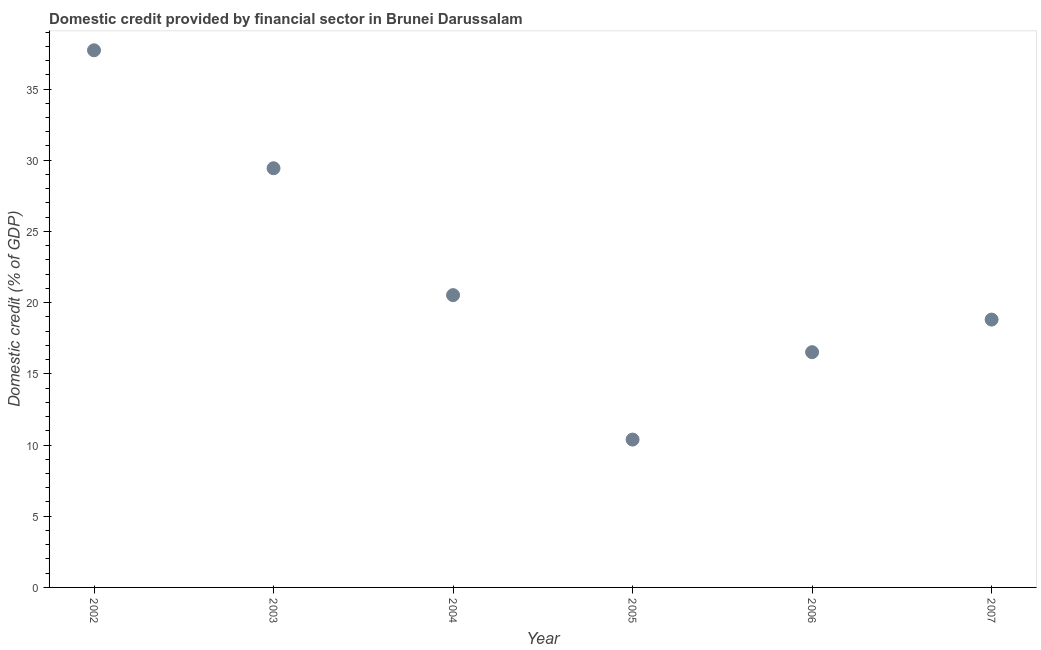What is the domestic credit provided by financial sector in 2005?
Offer a very short reply. 10.38. Across all years, what is the maximum domestic credit provided by financial sector?
Offer a terse response. 37.72. Across all years, what is the minimum domestic credit provided by financial sector?
Offer a very short reply. 10.38. In which year was the domestic credit provided by financial sector minimum?
Ensure brevity in your answer.  2005. What is the sum of the domestic credit provided by financial sector?
Your answer should be compact. 133.39. What is the difference between the domestic credit provided by financial sector in 2004 and 2005?
Keep it short and to the point. 10.14. What is the average domestic credit provided by financial sector per year?
Your answer should be very brief. 22.23. What is the median domestic credit provided by financial sector?
Provide a succinct answer. 19.67. What is the ratio of the domestic credit provided by financial sector in 2003 to that in 2007?
Keep it short and to the point. 1.57. Is the difference between the domestic credit provided by financial sector in 2002 and 2004 greater than the difference between any two years?
Ensure brevity in your answer.  No. What is the difference between the highest and the second highest domestic credit provided by financial sector?
Your answer should be very brief. 8.28. What is the difference between the highest and the lowest domestic credit provided by financial sector?
Provide a short and direct response. 27.34. What is the difference between two consecutive major ticks on the Y-axis?
Your answer should be compact. 5. Are the values on the major ticks of Y-axis written in scientific E-notation?
Ensure brevity in your answer.  No. Does the graph contain grids?
Make the answer very short. No. What is the title of the graph?
Offer a very short reply. Domestic credit provided by financial sector in Brunei Darussalam. What is the label or title of the Y-axis?
Your answer should be very brief. Domestic credit (% of GDP). What is the Domestic credit (% of GDP) in 2002?
Keep it short and to the point. 37.72. What is the Domestic credit (% of GDP) in 2003?
Make the answer very short. 29.44. What is the Domestic credit (% of GDP) in 2004?
Give a very brief answer. 20.53. What is the Domestic credit (% of GDP) in 2005?
Ensure brevity in your answer.  10.38. What is the Domestic credit (% of GDP) in 2006?
Your response must be concise. 16.52. What is the Domestic credit (% of GDP) in 2007?
Offer a very short reply. 18.81. What is the difference between the Domestic credit (% of GDP) in 2002 and 2003?
Provide a succinct answer. 8.28. What is the difference between the Domestic credit (% of GDP) in 2002 and 2004?
Keep it short and to the point. 17.19. What is the difference between the Domestic credit (% of GDP) in 2002 and 2005?
Provide a succinct answer. 27.34. What is the difference between the Domestic credit (% of GDP) in 2002 and 2006?
Your answer should be compact. 21.2. What is the difference between the Domestic credit (% of GDP) in 2002 and 2007?
Keep it short and to the point. 18.91. What is the difference between the Domestic credit (% of GDP) in 2003 and 2004?
Ensure brevity in your answer.  8.91. What is the difference between the Domestic credit (% of GDP) in 2003 and 2005?
Your answer should be compact. 19.05. What is the difference between the Domestic credit (% of GDP) in 2003 and 2006?
Your response must be concise. 12.92. What is the difference between the Domestic credit (% of GDP) in 2003 and 2007?
Your answer should be compact. 10.63. What is the difference between the Domestic credit (% of GDP) in 2004 and 2005?
Keep it short and to the point. 10.14. What is the difference between the Domestic credit (% of GDP) in 2004 and 2006?
Provide a succinct answer. 4.01. What is the difference between the Domestic credit (% of GDP) in 2004 and 2007?
Offer a very short reply. 1.72. What is the difference between the Domestic credit (% of GDP) in 2005 and 2006?
Offer a very short reply. -6.14. What is the difference between the Domestic credit (% of GDP) in 2005 and 2007?
Provide a short and direct response. -8.43. What is the difference between the Domestic credit (% of GDP) in 2006 and 2007?
Your response must be concise. -2.29. What is the ratio of the Domestic credit (% of GDP) in 2002 to that in 2003?
Ensure brevity in your answer.  1.28. What is the ratio of the Domestic credit (% of GDP) in 2002 to that in 2004?
Ensure brevity in your answer.  1.84. What is the ratio of the Domestic credit (% of GDP) in 2002 to that in 2005?
Make the answer very short. 3.63. What is the ratio of the Domestic credit (% of GDP) in 2002 to that in 2006?
Provide a succinct answer. 2.28. What is the ratio of the Domestic credit (% of GDP) in 2002 to that in 2007?
Your answer should be very brief. 2. What is the ratio of the Domestic credit (% of GDP) in 2003 to that in 2004?
Offer a terse response. 1.43. What is the ratio of the Domestic credit (% of GDP) in 2003 to that in 2005?
Offer a terse response. 2.83. What is the ratio of the Domestic credit (% of GDP) in 2003 to that in 2006?
Give a very brief answer. 1.78. What is the ratio of the Domestic credit (% of GDP) in 2003 to that in 2007?
Offer a terse response. 1.56. What is the ratio of the Domestic credit (% of GDP) in 2004 to that in 2005?
Ensure brevity in your answer.  1.98. What is the ratio of the Domestic credit (% of GDP) in 2004 to that in 2006?
Make the answer very short. 1.24. What is the ratio of the Domestic credit (% of GDP) in 2004 to that in 2007?
Make the answer very short. 1.09. What is the ratio of the Domestic credit (% of GDP) in 2005 to that in 2006?
Your response must be concise. 0.63. What is the ratio of the Domestic credit (% of GDP) in 2005 to that in 2007?
Make the answer very short. 0.55. What is the ratio of the Domestic credit (% of GDP) in 2006 to that in 2007?
Keep it short and to the point. 0.88. 